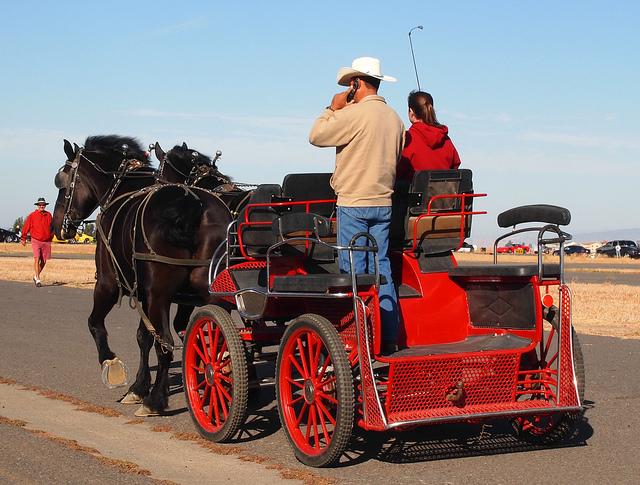Are the horses wearing horseshoes?
Answer briefly. Yes. What is in the cart?
Be succinct. People. How many girls are visible?
Write a very short answer. 1. From what cultural group of people does this man come from?
Concise answer only. Western. What color is the horse?
Short answer required. Black. What is he wearing on his head?
Answer briefly. Hat. Is this an active person?
Give a very brief answer. No. Is there a star in this picture?
Be succinct. No. What color is the wagon?
Give a very brief answer. Red. What kind of hat is this man wearing?
Be succinct. Cowboy. What type of horse is this?
Give a very brief answer. Black. Is it a brand new carriage?
Write a very short answer. No. What is to the right of the cart?
Write a very short answer. Cars. How many horses are in the photo?
Concise answer only. 2. Is the horse well fed?
Answer briefly. Yes. How many horses are pulling the carriage?
Be succinct. 2. 